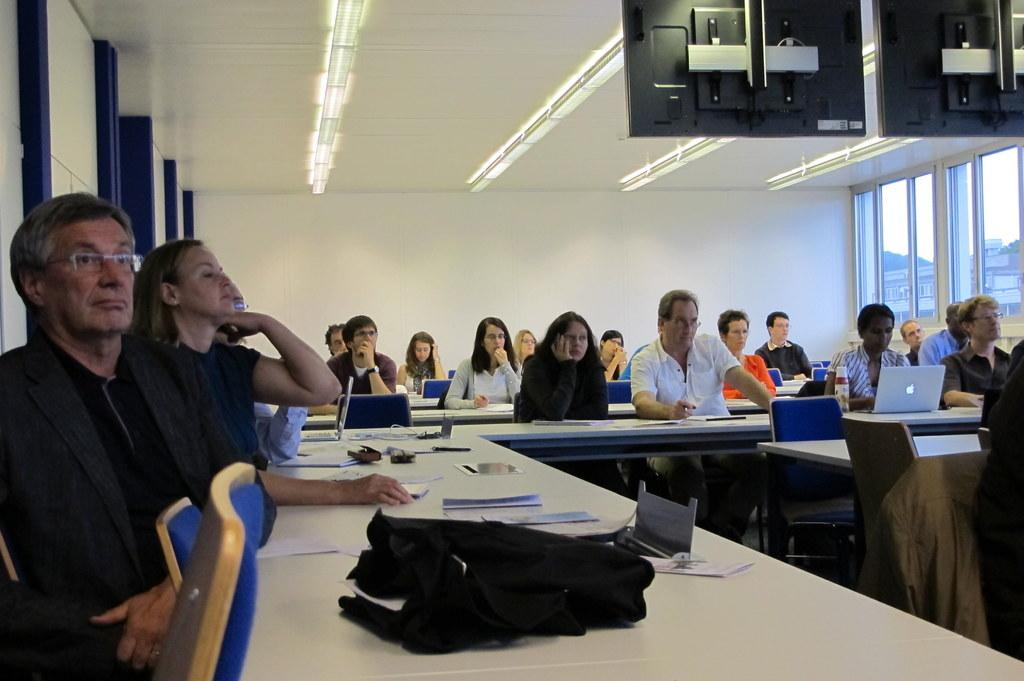How many people are in the image? There is a group of people in the image, but the exact number cannot be determined from the provided facts. What are the people doing in the image? The people are sitting in front of a table. What is on the table in the image? There are papers and objects on the table. What is the level of coughing in the image? There is no mention of coughing in the image, so it cannot be determined. 